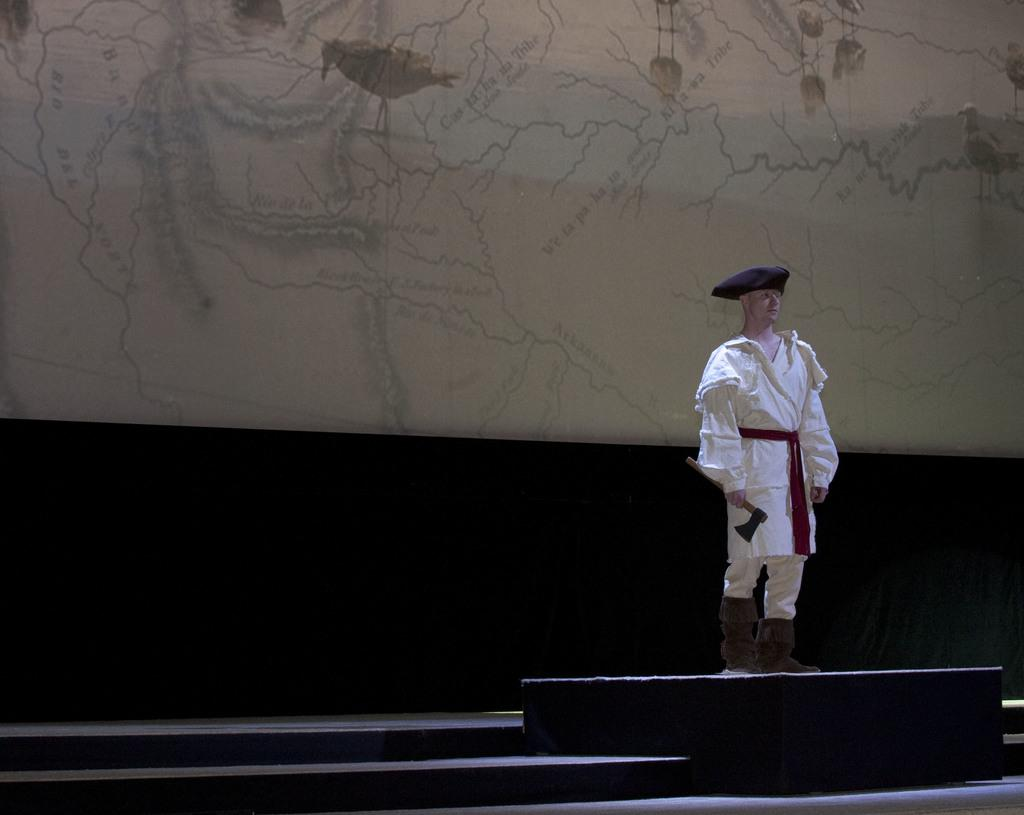What is the person wearing on the right side of the image? There is a person wearing a white dress on the right side of the image. What can be seen in the background of the image? There is a wall in the background of the image. What architectural feature is present at the bottom of the image? There is a staircase at the bottom of the image. What arithmetic problem is the person solving in the image? There is no arithmetic problem visible in the image, as it only shows a person wearing a white dress, a wall in the background, and a staircase at the bottom. 